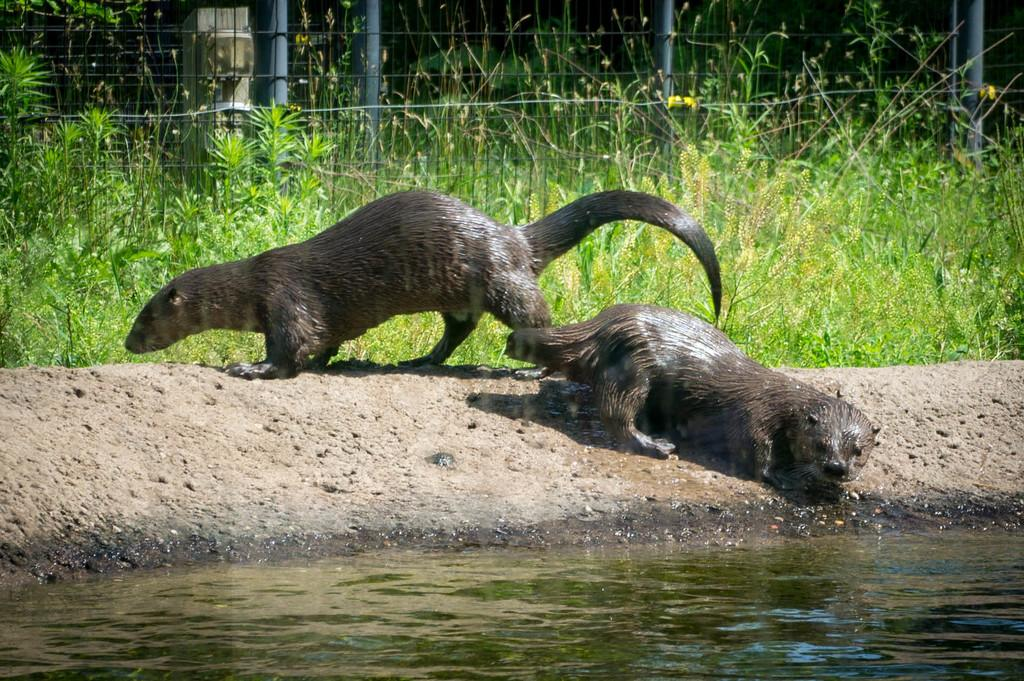What type of animals can be seen on the sand in the image? There are animals on the sand in the image, but the specific type of animals is not mentioned in the facts. What can be seen at the bottom of the image? There is water visible at the bottom of the image. What type of vegetation is in the background of the image? There are plants and grass in the background of the image. What type of barrier is present in the image? There is a fencing in the image. Can you see any giants walking on the sand in the image? No, there are no giants present in the image. What type of pets can be seen playing with the animals on the sand? There are no pets mentioned or visible in the image. 